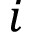Convert formula to latex. <formula><loc_0><loc_0><loc_500><loc_500>i</formula> 